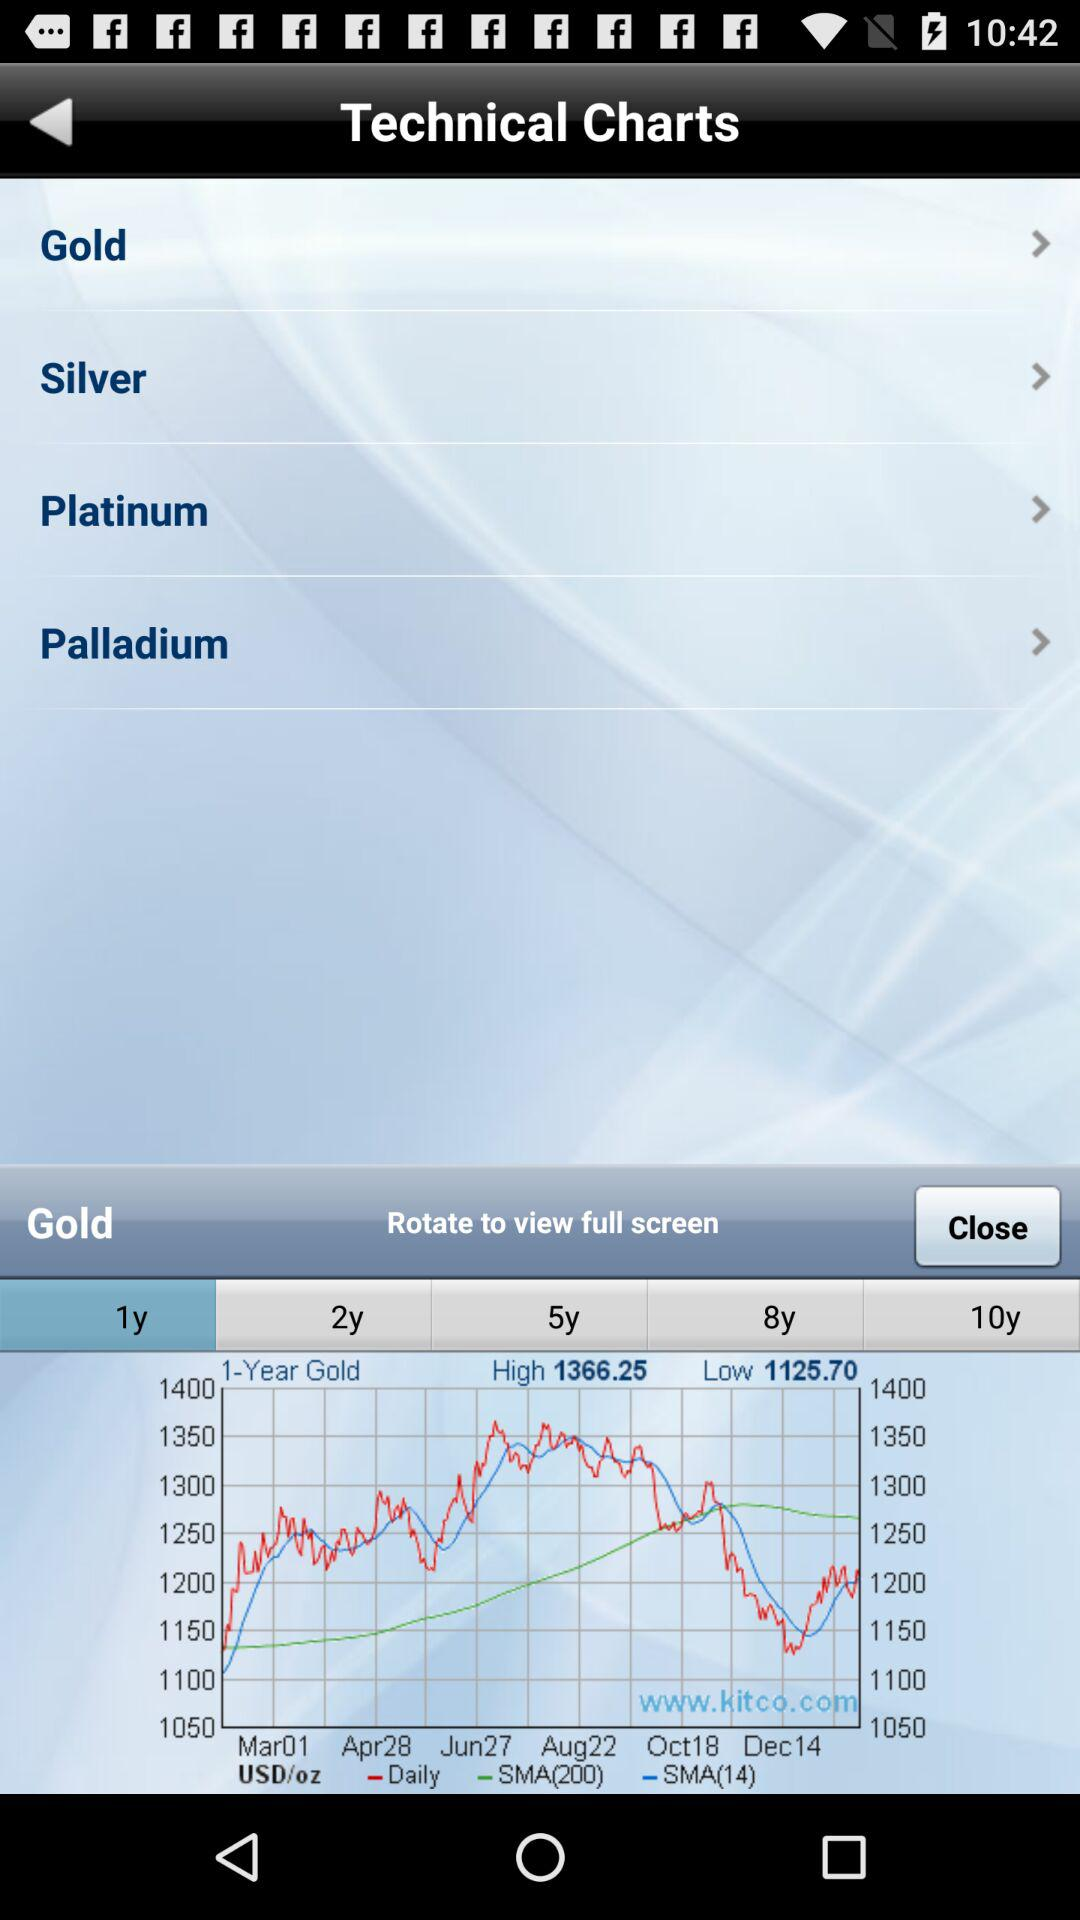How many items are in "Silver"?
When the provided information is insufficient, respond with <no answer>. <no answer> 